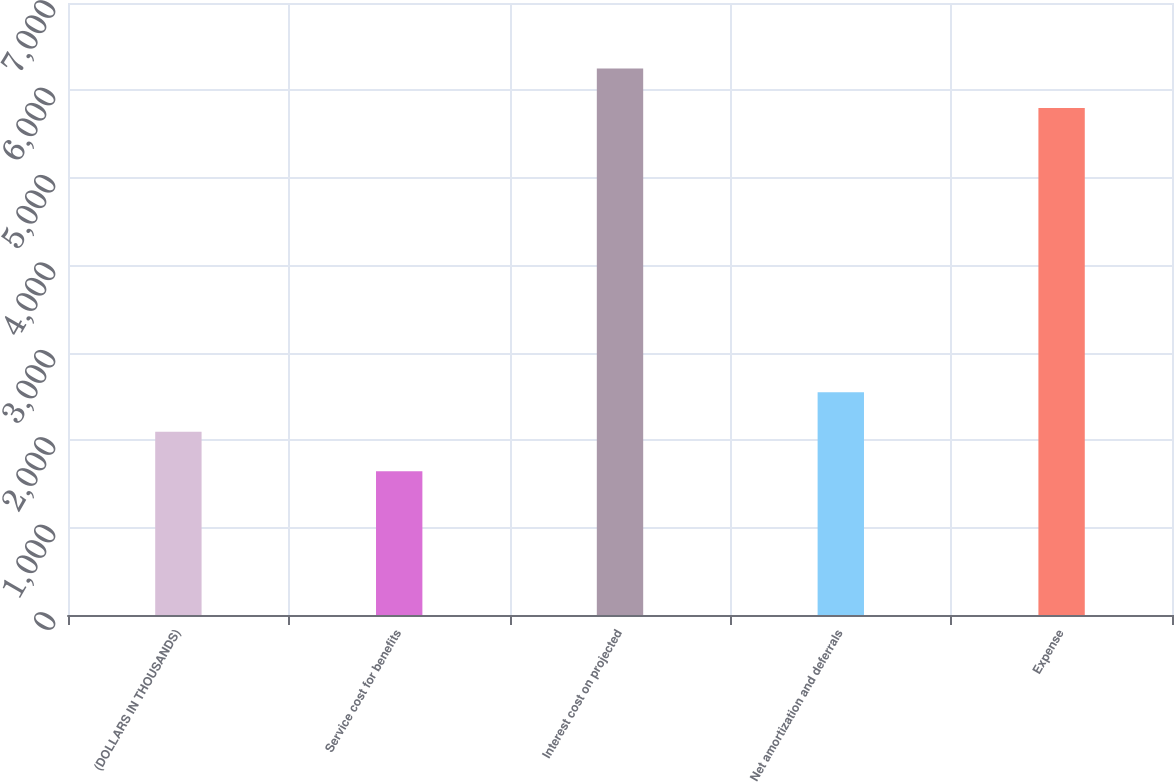Convert chart. <chart><loc_0><loc_0><loc_500><loc_500><bar_chart><fcel>(DOLLARS IN THOUSANDS)<fcel>Service cost for benefits<fcel>Interest cost on projected<fcel>Net amortization and deferrals<fcel>Expense<nl><fcel>2096.2<fcel>1644<fcel>6250.2<fcel>2548.4<fcel>5798<nl></chart> 